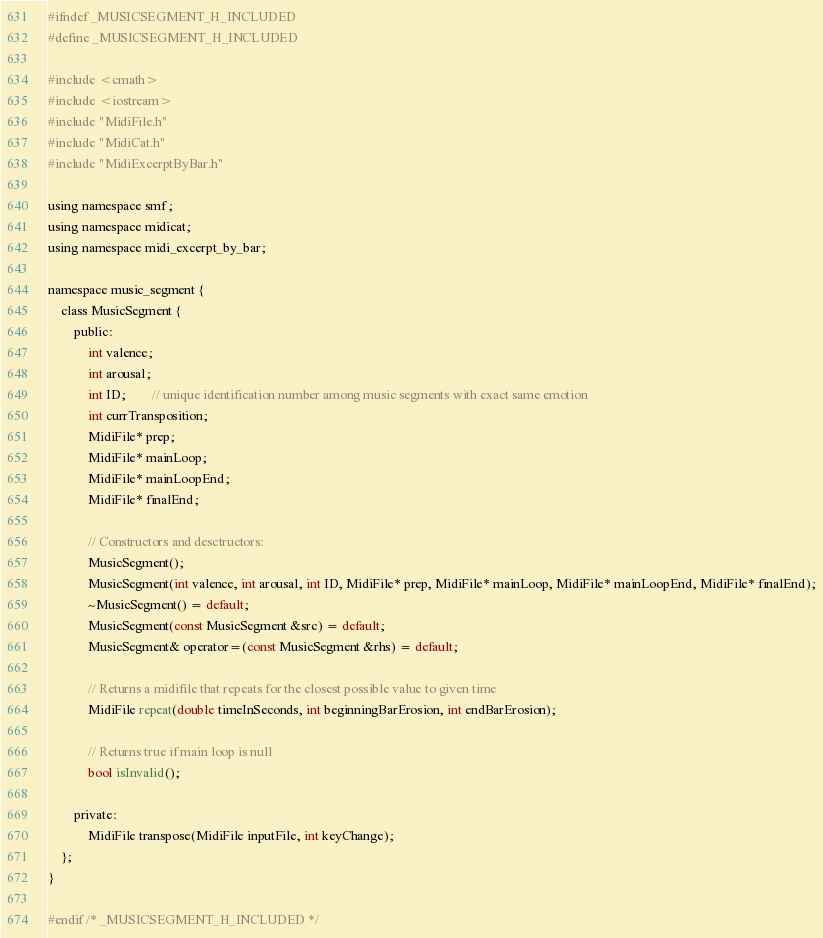<code> <loc_0><loc_0><loc_500><loc_500><_C_>#ifndef _MUSICSEGMENT_H_INCLUDED
#define _MUSICSEGMENT_H_INCLUDED

#include <cmath>
#include <iostream>
#include "MidiFile.h"
#include "MidiCat.h"
#include "MidiExcerptByBar.h"

using namespace smf;
using namespace midicat;
using namespace midi_excerpt_by_bar;

namespace music_segment {
	class MusicSegment {
		public:
			int valence;
			int arousal;
			int ID;		// unique identification number among music segments with exact same emotion
			int currTransposition;
			MidiFile* prep;
			MidiFile* mainLoop;
			MidiFile* mainLoopEnd;
			MidiFile* finalEnd;
			
			// Constructors and desctructors:
			MusicSegment();
			MusicSegment(int valence, int arousal, int ID, MidiFile* prep, MidiFile* mainLoop, MidiFile* mainLoopEnd, MidiFile* finalEnd);
			~MusicSegment() = default;
			MusicSegment(const MusicSegment &src) = default;
			MusicSegment& operator=(const MusicSegment &rhs) = default;
			
			// Returns a midifile that repeats for the closest possible value to given time
			MidiFile repeat(double timeInSeconds, int beginningBarErosion, int endBarErosion);
			
			// Returns true if main loop is null
			bool isInvalid();

		private:
			MidiFile transpose(MidiFile inputFile, int keyChange);
	};
}

#endif /* _MUSICSEGMENT_H_INCLUDED */</code> 